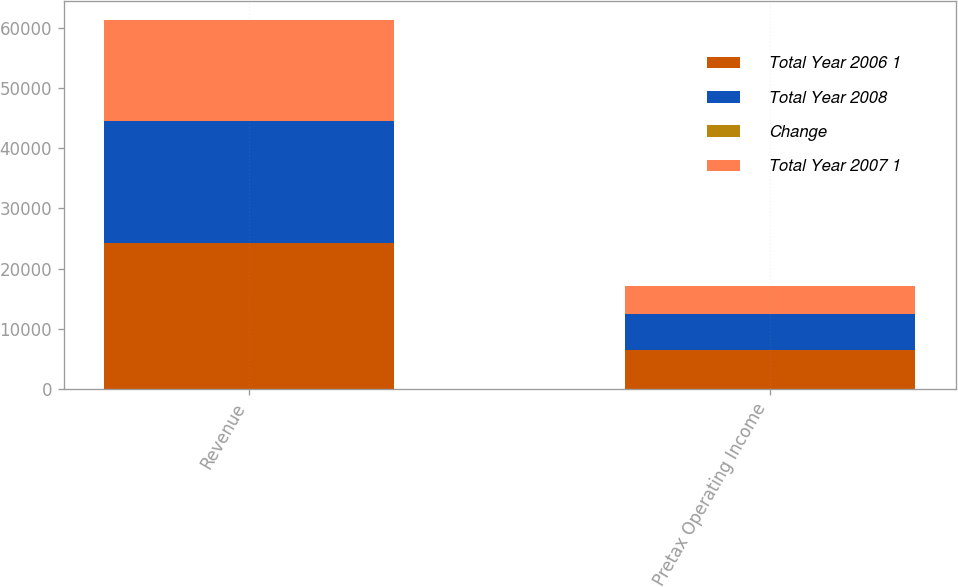Convert chart. <chart><loc_0><loc_0><loc_500><loc_500><stacked_bar_chart><ecel><fcel>Revenue<fcel>Pretax Operating Income<nl><fcel>Total Year 2006 1<fcel>24282<fcel>6505<nl><fcel>Total Year 2008<fcel>20306<fcel>5959<nl><fcel>Change<fcel>20<fcel>9<nl><fcel>Total Year 2007 1<fcel>16762<fcel>4644<nl></chart> 